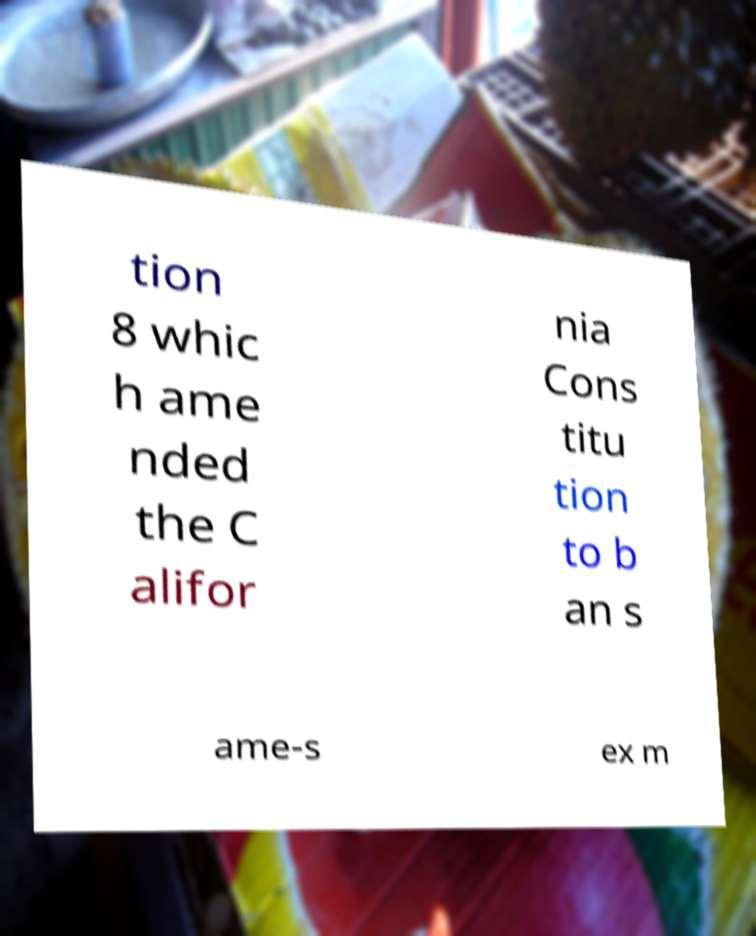Could you extract and type out the text from this image? tion 8 whic h ame nded the C alifor nia Cons titu tion to b an s ame-s ex m 